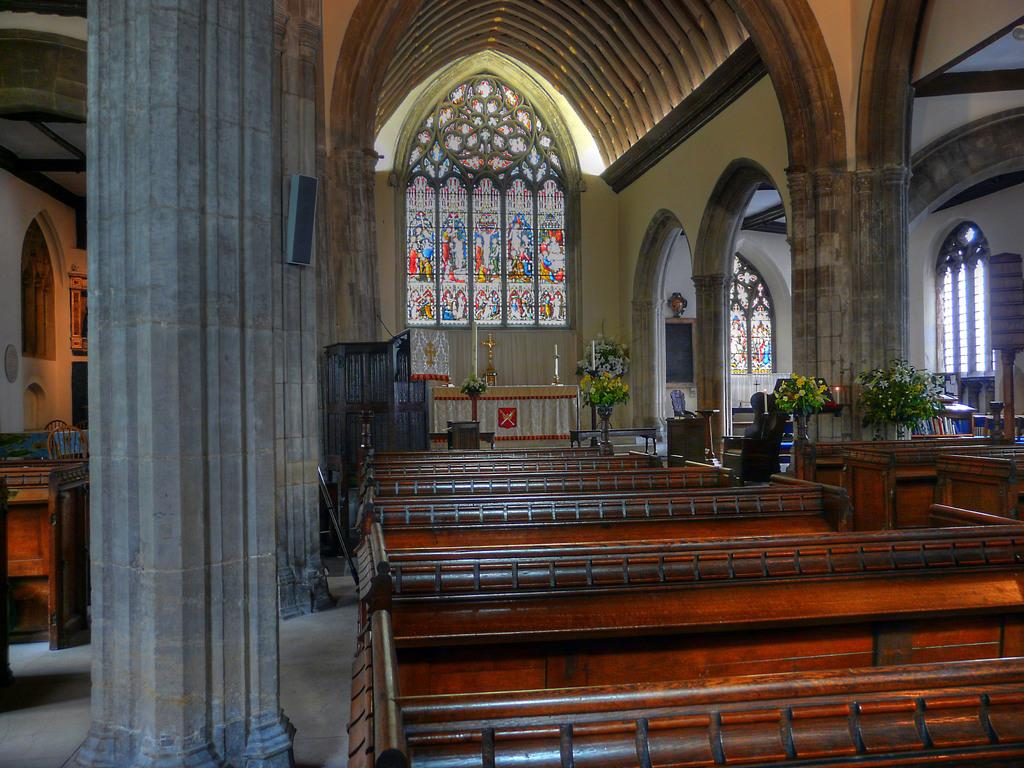What type of building is shown in the image? The image depicts the inside of a church. What type of seating is available in the church? There are benches in the image. Are there any decorative elements in the image? Yes, there are plants in the image. What might be used for displaying information or announcements in the church? There is a notice board in the board in the image. What type of nut can be seen on the floor in the image? There is no nut present on the floor in the image. How many people are seen slipping on the floor in the image? There are no people slipping on the floor in the image. 